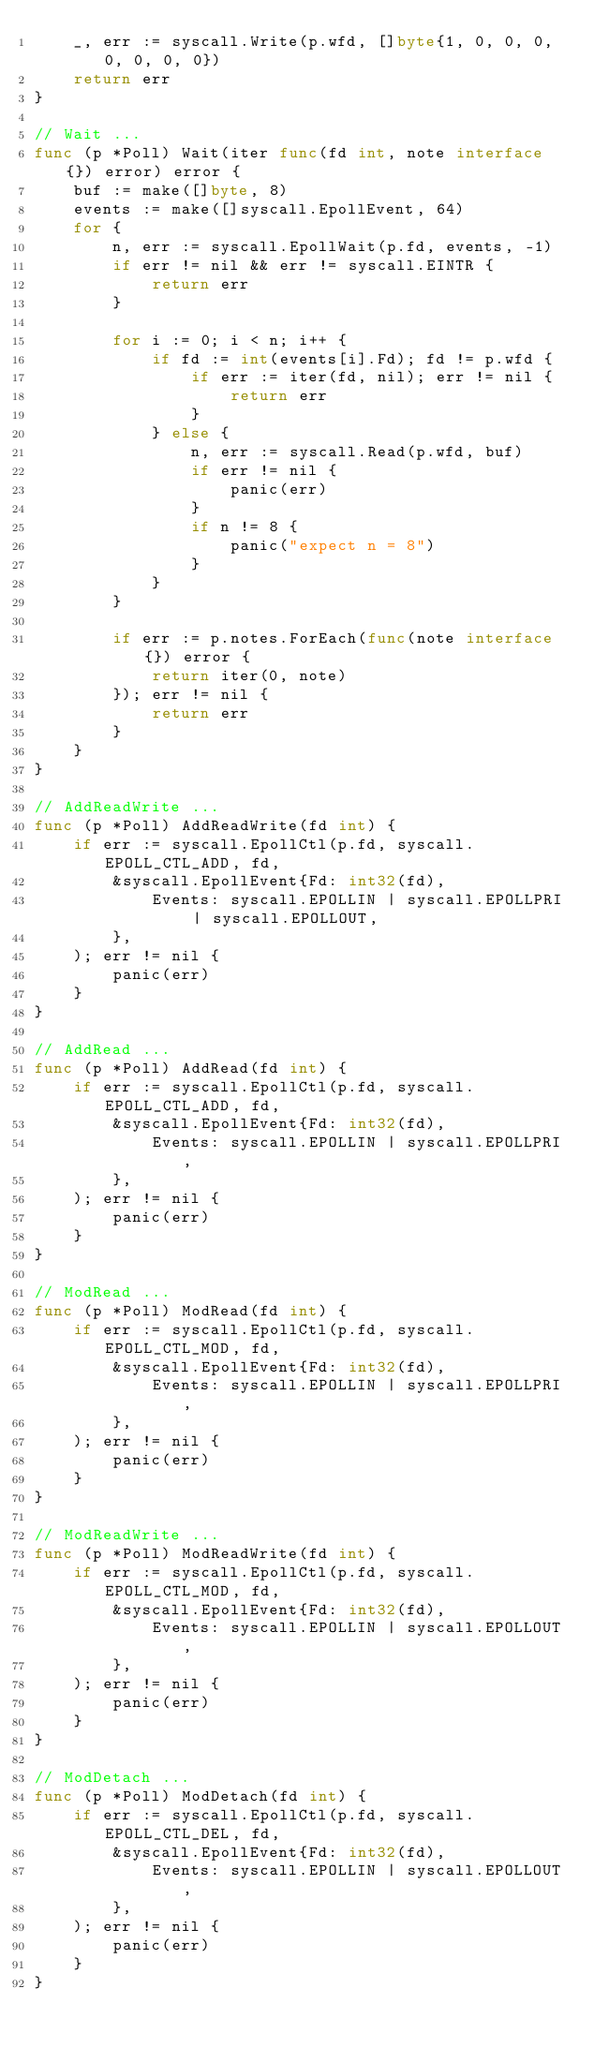<code> <loc_0><loc_0><loc_500><loc_500><_Go_>	_, err := syscall.Write(p.wfd, []byte{1, 0, 0, 0, 0, 0, 0, 0})
	return err
}

// Wait ...
func (p *Poll) Wait(iter func(fd int, note interface{}) error) error {
	buf := make([]byte, 8)
	events := make([]syscall.EpollEvent, 64)
	for {
		n, err := syscall.EpollWait(p.fd, events, -1)
		if err != nil && err != syscall.EINTR {
			return err
		}

		for i := 0; i < n; i++ {
			if fd := int(events[i].Fd); fd != p.wfd {
				if err := iter(fd, nil); err != nil {
					return err
				}
			} else {
				n, err := syscall.Read(p.wfd, buf)
				if err != nil {
					panic(err)
				}
				if n != 8 {
					panic("expect n = 8")
				}
			}
		}

		if err := p.notes.ForEach(func(note interface{}) error {
			return iter(0, note)
		}); err != nil {
			return err
		}
	}
}

// AddReadWrite ...
func (p *Poll) AddReadWrite(fd int) {
	if err := syscall.EpollCtl(p.fd, syscall.EPOLL_CTL_ADD, fd,
		&syscall.EpollEvent{Fd: int32(fd),
			Events: syscall.EPOLLIN | syscall.EPOLLPRI | syscall.EPOLLOUT,
		},
	); err != nil {
		panic(err)
	}
}

// AddRead ...
func (p *Poll) AddRead(fd int) {
	if err := syscall.EpollCtl(p.fd, syscall.EPOLL_CTL_ADD, fd,
		&syscall.EpollEvent{Fd: int32(fd),
			Events: syscall.EPOLLIN | syscall.EPOLLPRI,
		},
	); err != nil {
		panic(err)
	}
}

// ModRead ...
func (p *Poll) ModRead(fd int) {
	if err := syscall.EpollCtl(p.fd, syscall.EPOLL_CTL_MOD, fd,
		&syscall.EpollEvent{Fd: int32(fd),
			Events: syscall.EPOLLIN | syscall.EPOLLPRI,
		},
	); err != nil {
		panic(err)
	}
}

// ModReadWrite ...
func (p *Poll) ModReadWrite(fd int) {
	if err := syscall.EpollCtl(p.fd, syscall.EPOLL_CTL_MOD, fd,
		&syscall.EpollEvent{Fd: int32(fd),
			Events: syscall.EPOLLIN | syscall.EPOLLOUT,
		},
	); err != nil {
		panic(err)
	}
}

// ModDetach ...
func (p *Poll) ModDetach(fd int) {
	if err := syscall.EpollCtl(p.fd, syscall.EPOLL_CTL_DEL, fd,
		&syscall.EpollEvent{Fd: int32(fd),
			Events: syscall.EPOLLIN | syscall.EPOLLOUT,
		},
	); err != nil {
		panic(err)
	}
}
</code> 